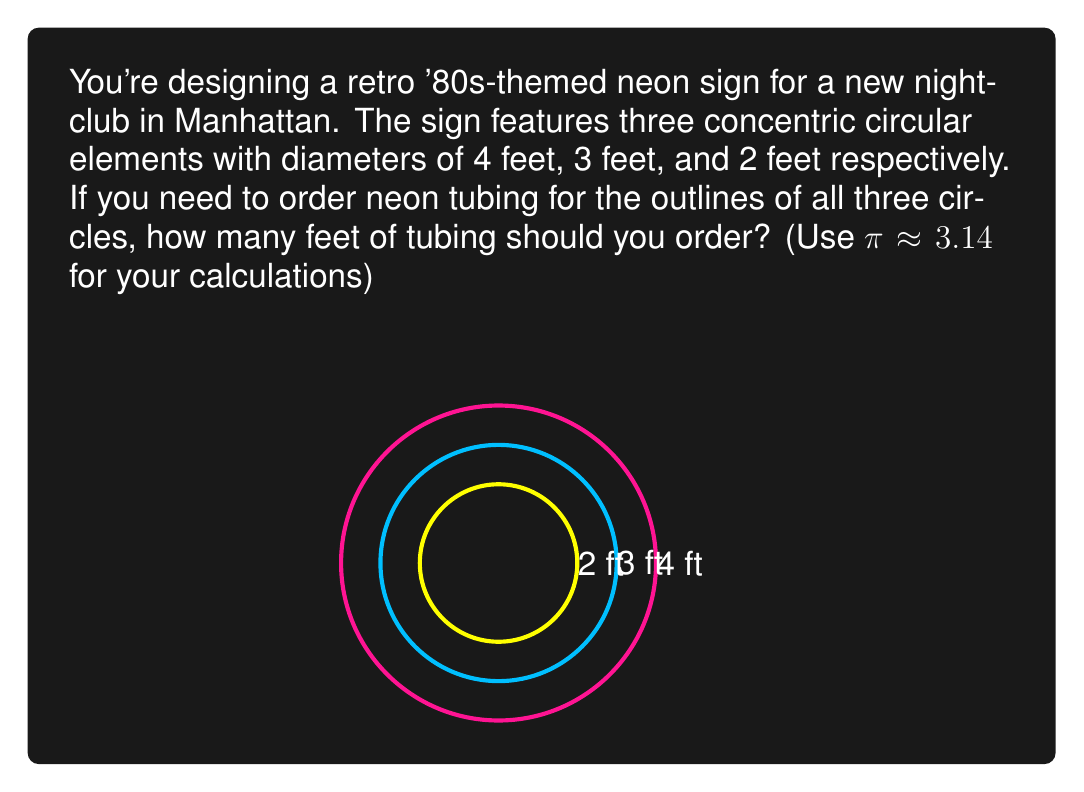Solve this math problem. To solve this problem, we need to calculate the circumference of each circular element and then sum them up. Let's break it down step-by-step:

1. Recall the formula for the circumference of a circle:
   $C = \pi d$, where $C$ is the circumference and $d$ is the diameter.

2. Calculate the circumference of each circle:

   a) Largest circle (4 ft diameter):
      $C_1 = \pi \cdot 4 \approx 3.14 \cdot 4 = 12.56$ ft

   b) Middle circle (3 ft diameter):
      $C_2 = \pi \cdot 3 \approx 3.14 \cdot 3 = 9.42$ ft

   c) Smallest circle (2 ft diameter):
      $C_3 = \pi \cdot 2 \approx 3.14 \cdot 2 = 6.28$ ft

3. Sum up the circumferences of all three circles:
   $C_{total} = C_1 + C_2 + C_3 = 12.56 + 9.42 + 6.28 = 28.26$ ft

Therefore, you should order approximately 28.26 feet of neon tubing to outline all three circular elements in your '80s-style neon sign.
Answer: $28.26$ feet of neon tubing 